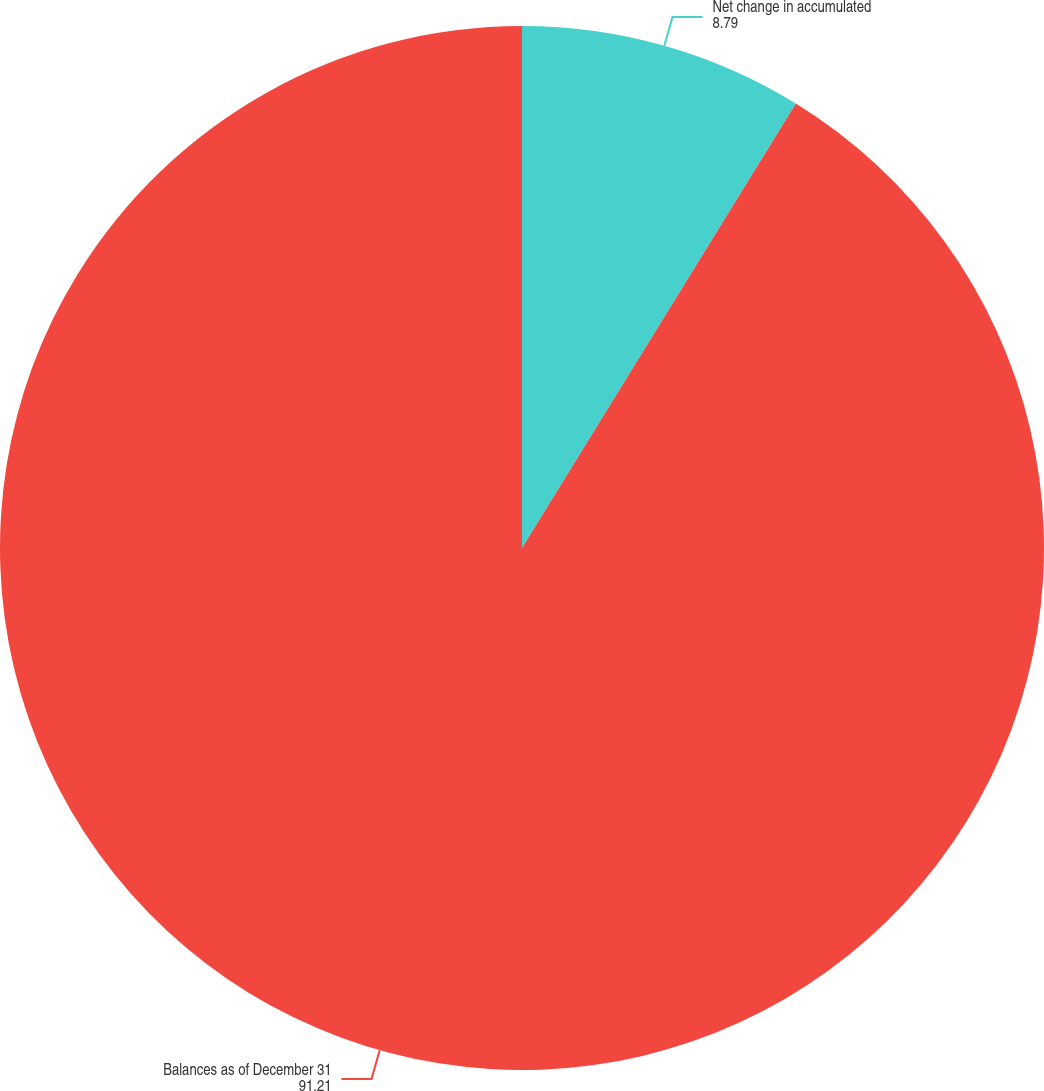<chart> <loc_0><loc_0><loc_500><loc_500><pie_chart><fcel>Net change in accumulated<fcel>Balances as of December 31<nl><fcel>8.79%<fcel>91.21%<nl></chart> 